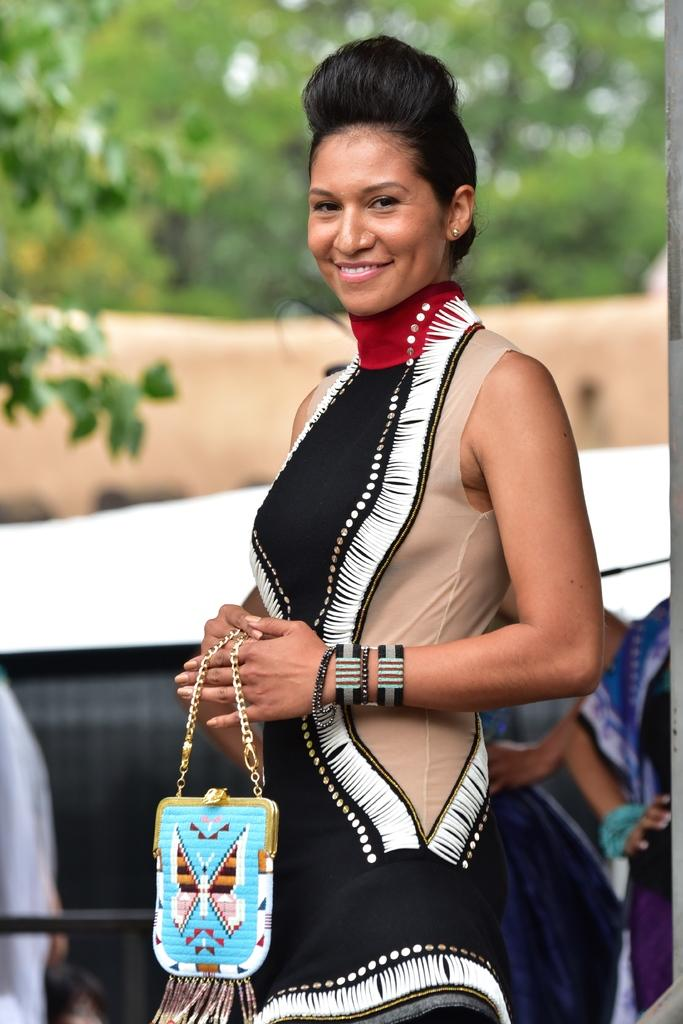What is the main subject of the image? The main subject of the image is a woman. Can you describe the woman's attire in the image? The woman is wearing a dress with a different color. What is the woman's hairstyle like in the image? The woman has a different hairstyle. What is the woman's facial expression in the image? The woman is smiling. What object is the woman holding in the image? The woman is holding a handbag. What type of natural environment is visible in the image? There are trees in the image. Can you tell me how many spots are on the woman's dress in the image? There are no spots visible on the woman's dress in the image. Is the woman in jail in the image? There is no indication of a jail or any imprisonment in the image. 